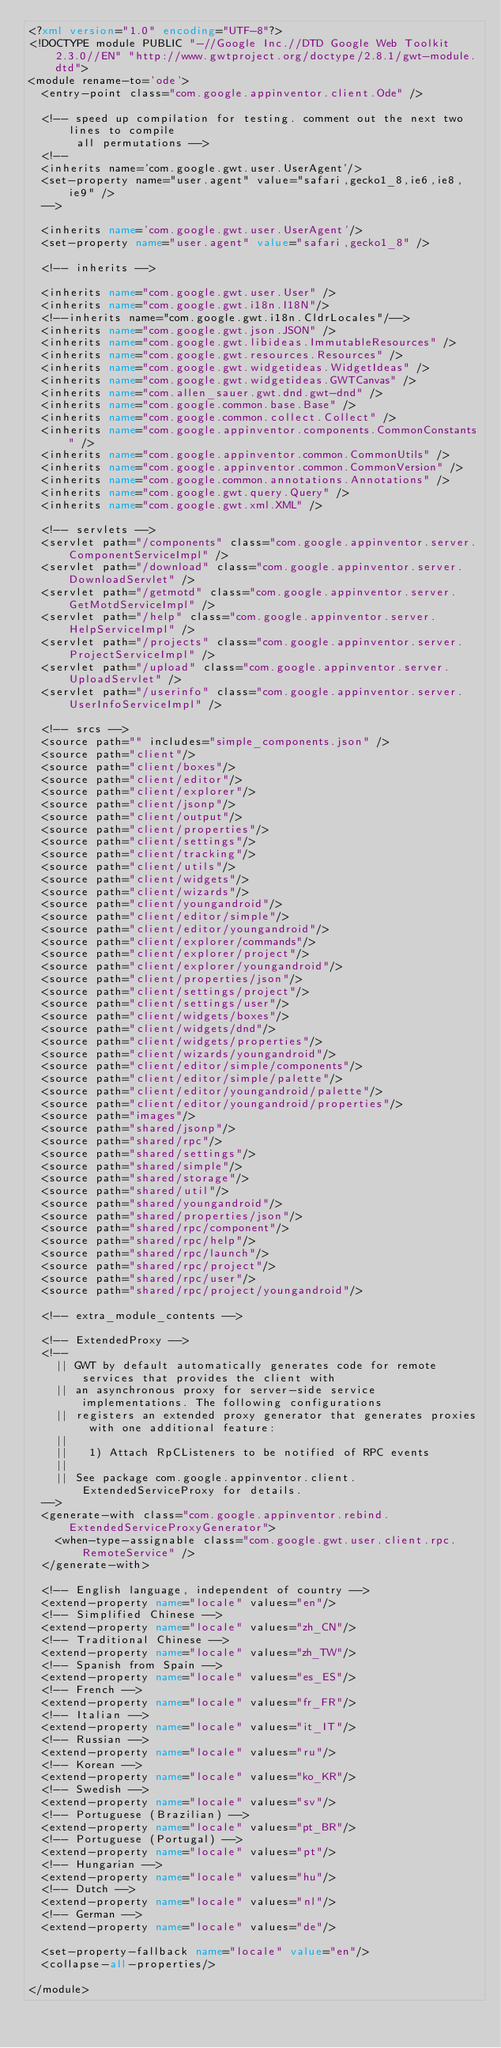Convert code to text. <code><loc_0><loc_0><loc_500><loc_500><_XML_><?xml version="1.0" encoding="UTF-8"?>
<!DOCTYPE module PUBLIC "-//Google Inc.//DTD Google Web Toolkit 2.3.0//EN" "http://www.gwtproject.org/doctype/2.8.1/gwt-module.dtd">
<module rename-to='ode'>
  <entry-point class="com.google.appinventor.client.Ode" />

  <!-- speed up compilation for testing. comment out the next two lines to compile
       all permutations -->
  <!--
  <inherits name='com.google.gwt.user.UserAgent'/>
  <set-property name="user.agent" value="safari,gecko1_8,ie6,ie8,ie9" />
  -->

  <inherits name='com.google.gwt.user.UserAgent'/>
  <set-property name="user.agent" value="safari,gecko1_8" />

  <!-- inherits -->

  <inherits name="com.google.gwt.user.User" />
  <inherits name="com.google.gwt.i18n.I18N"/>
  <!--inherits name="com.google.gwt.i18n.CldrLocales"/-->
  <inherits name="com.google.gwt.json.JSON" />
  <inherits name="com.google.gwt.libideas.ImmutableResources" />
  <inherits name="com.google.gwt.resources.Resources" />
  <inherits name="com.google.gwt.widgetideas.WidgetIdeas" />
  <inherits name="com.google.gwt.widgetideas.GWTCanvas" />
  <inherits name="com.allen_sauer.gwt.dnd.gwt-dnd" />
  <inherits name="com.google.common.base.Base" />
  <inherits name="com.google.common.collect.Collect" />
  <inherits name="com.google.appinventor.components.CommonConstants" />
  <inherits name="com.google.appinventor.common.CommonUtils" />
  <inherits name="com.google.appinventor.common.CommonVersion" />
  <inherits name="com.google.common.annotations.Annotations" />
  <inherits name="com.google.gwt.query.Query" />
  <inherits name="com.google.gwt.xml.XML" />

  <!-- servlets -->
  <servlet path="/components" class="com.google.appinventor.server.ComponentServiceImpl" />
  <servlet path="/download" class="com.google.appinventor.server.DownloadServlet" />
  <servlet path="/getmotd" class="com.google.appinventor.server.GetMotdServiceImpl" />
  <servlet path="/help" class="com.google.appinventor.server.HelpServiceImpl" />
  <servlet path="/projects" class="com.google.appinventor.server.ProjectServiceImpl" />
  <servlet path="/upload" class="com.google.appinventor.server.UploadServlet" />
  <servlet path="/userinfo" class="com.google.appinventor.server.UserInfoServiceImpl" />

  <!-- srcs -->
  <source path="" includes="simple_components.json" />
  <source path="client"/>
  <source path="client/boxes"/>
  <source path="client/editor"/>
  <source path="client/explorer"/>
  <source path="client/jsonp"/>
  <source path="client/output"/>
  <source path="client/properties"/>
  <source path="client/settings"/>
  <source path="client/tracking"/>
  <source path="client/utils"/>
  <source path="client/widgets"/>
  <source path="client/wizards"/>
  <source path="client/youngandroid"/>
  <source path="client/editor/simple"/>
  <source path="client/editor/youngandroid"/>
  <source path="client/explorer/commands"/>
  <source path="client/explorer/project"/>
  <source path="client/explorer/youngandroid"/>
  <source path="client/properties/json"/>
  <source path="client/settings/project"/>
  <source path="client/settings/user"/>
  <source path="client/widgets/boxes"/>
  <source path="client/widgets/dnd"/>
  <source path="client/widgets/properties"/>
  <source path="client/wizards/youngandroid"/>
  <source path="client/editor/simple/components"/>
  <source path="client/editor/simple/palette"/>
  <source path="client/editor/youngandroid/palette"/>
  <source path="client/editor/youngandroid/properties"/>
  <source path="images"/>
  <source path="shared/jsonp"/>
  <source path="shared/rpc"/>
  <source path="shared/settings"/>
  <source path="shared/simple"/>
  <source path="shared/storage"/>
  <source path="shared/util"/>
  <source path="shared/youngandroid"/>
  <source path="shared/properties/json"/>
  <source path="shared/rpc/component"/>
  <source path="shared/rpc/help"/>
  <source path="shared/rpc/launch"/>
  <source path="shared/rpc/project"/>
  <source path="shared/rpc/user"/>
  <source path="shared/rpc/project/youngandroid"/>

  <!-- extra_module_contents -->

  <!-- ExtendedProxy -->
  <!--
    || GWT by default automatically generates code for remote services that provides the client with
    || an asynchronous proxy for server-side service implementations. The following configurations
    || registers an extended proxy generator that generates proxies with one additional feature:
    ||
    ||   1) Attach RpCListeners to be notified of RPC events
    ||
    || See package com.google.appinventor.client.ExtendedServiceProxy for details.
  -->
  <generate-with class="com.google.appinventor.rebind.ExtendedServiceProxyGenerator">
    <when-type-assignable class="com.google.gwt.user.client.rpc.RemoteService" />
  </generate-with>

  <!-- English language, independent of country -->
  <extend-property name="locale" values="en"/>
  <!-- Simplified Chinese -->
  <extend-property name="locale" values="zh_CN"/>
  <!-- Traditional Chinese -->
  <extend-property name="locale" values="zh_TW"/>
  <!-- Spanish from Spain -->
  <extend-property name="locale" values="es_ES"/>
  <!-- French -->
  <extend-property name="locale" values="fr_FR"/>
  <!-- Italian -->
  <extend-property name="locale" values="it_IT"/>
  <!-- Russian -->
  <extend-property name="locale" values="ru"/>
  <!-- Korean -->
  <extend-property name="locale" values="ko_KR"/>
  <!-- Swedish -->
  <extend-property name="locale" values="sv"/>
  <!-- Portuguese (Brazilian) -->
  <extend-property name="locale" values="pt_BR"/>
  <!-- Portuguese (Portugal) -->
  <extend-property name="locale" values="pt"/>
  <!-- Hungarian -->
  <extend-property name="locale" values="hu"/>
  <!-- Dutch -->
  <extend-property name="locale" values="nl"/>
  <!-- German -->
  <extend-property name="locale" values="de"/>

  <set-property-fallback name="locale" value="en"/>
  <collapse-all-properties/>

</module>
</code> 